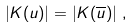<formula> <loc_0><loc_0><loc_500><loc_500>\left | K ( u ) \right | = \left | K ( \overline { u } ) \right | \, ,</formula> 